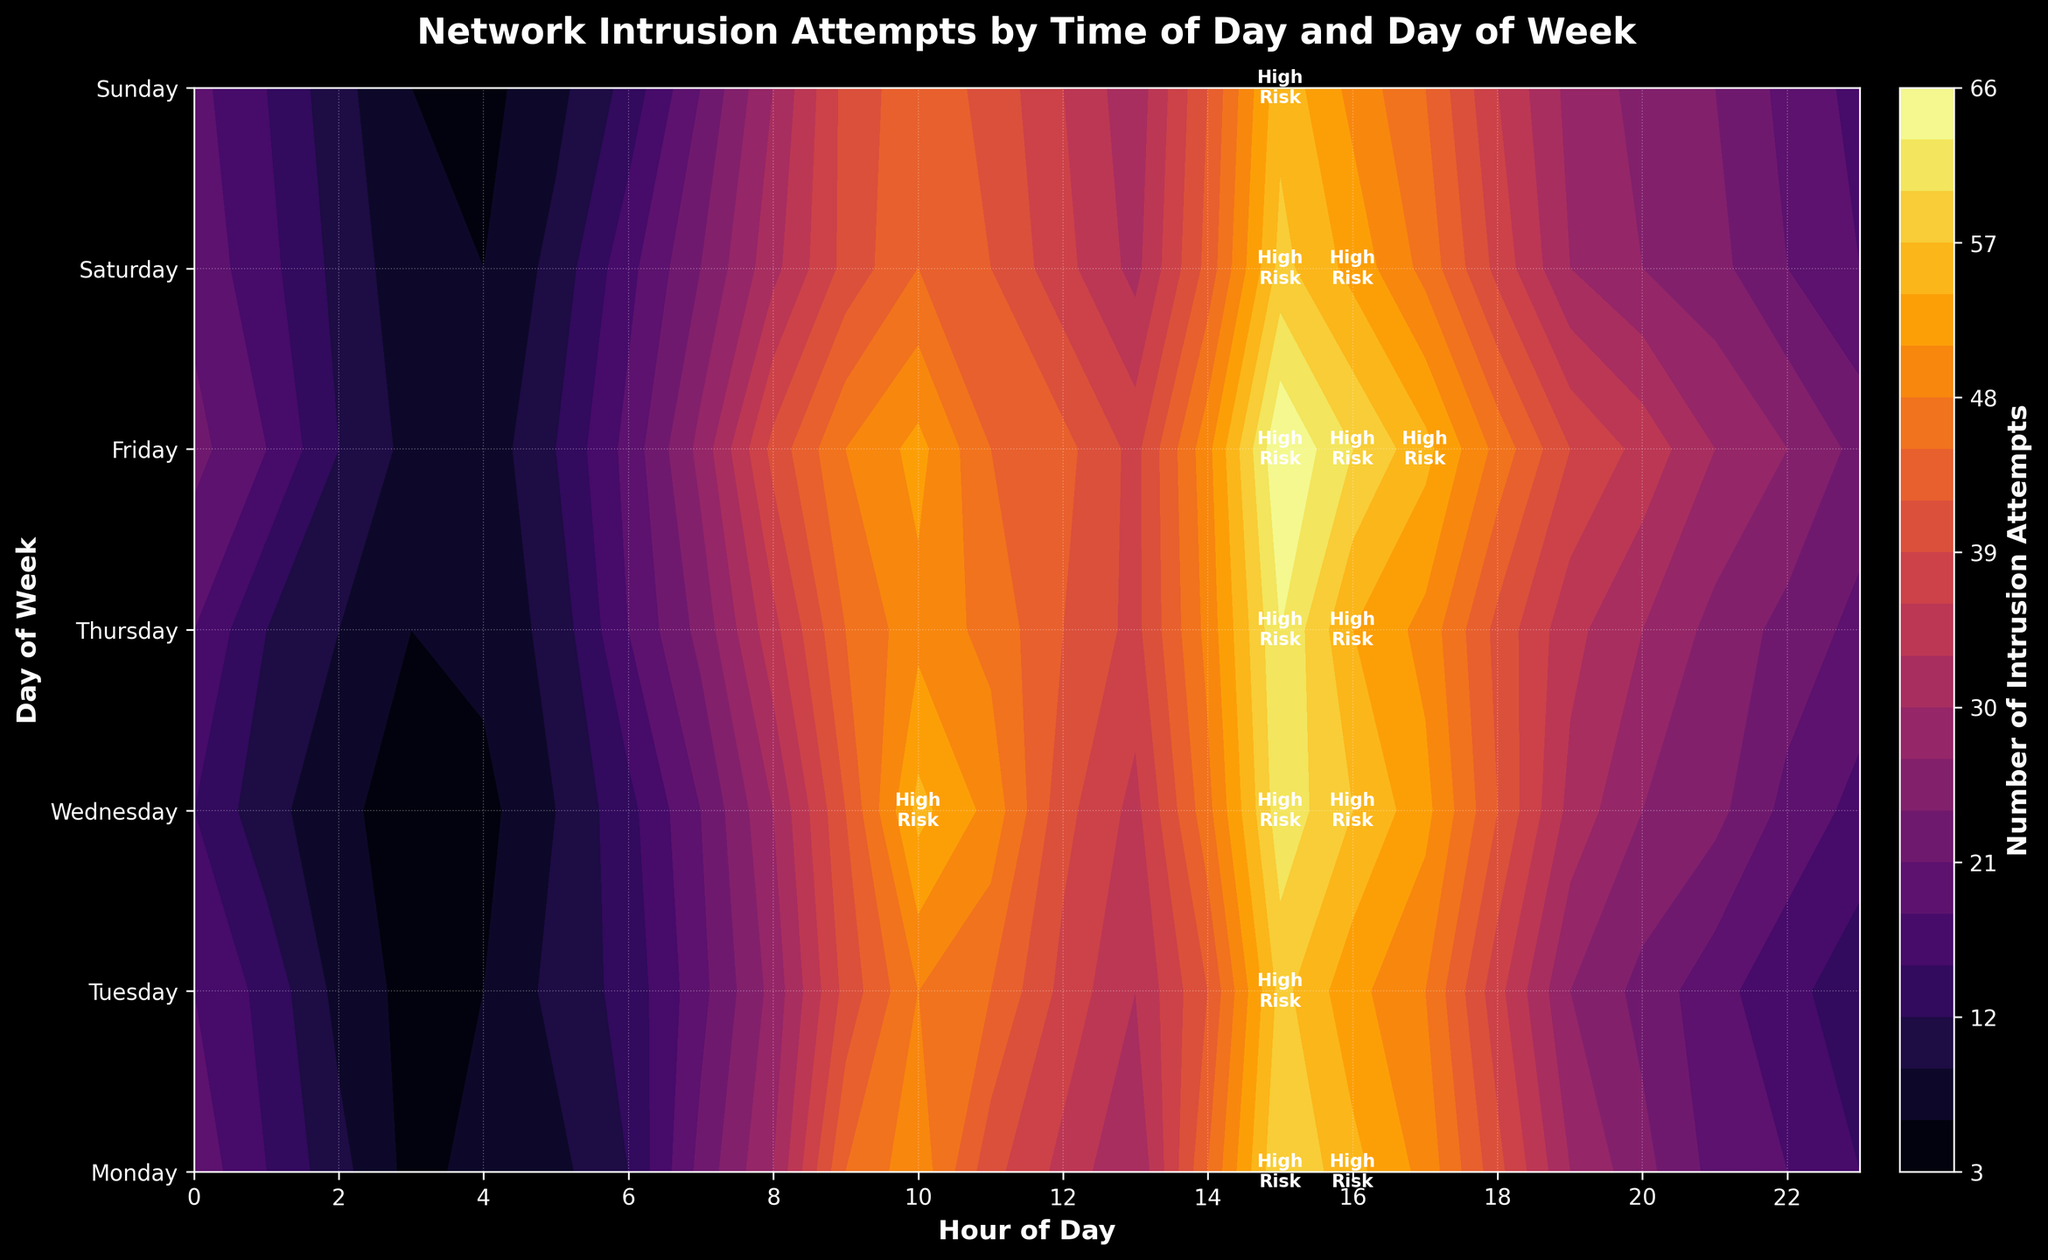What is the title of the figure? The title of the figure is located at the top and is clearly stated in the figure. The title summarizes the content of the plot.
Answer: Network Intrusion Attempts by Time of Day and Day of Week How many intrusion attempts are there at 14:00 on Friday? Find the intersection of "Friday" and the hour "14" in the figure to locate the value representing intrusion attempts at that specific time.
Answer: 50 Which day and hour combination shows the highest number of intrusion attempts? Look for the highest contour level which visually represents the peak value in the plot. Identify the corresponding day and hour on the axes of the plot.
Answer: Friday at 15:00 How does the number of intrusion attempts at 3:00 on Wednesday compare to 3:00 on Thursday? Check the number of intrusion attempts at 3:00 on Wednesday and compare it to the value at 3:00 on Thursday by examining the plot at these intersections.
Answer: Wednesday has 4 attempts and Thursday has 6 attempts Is there any day that appears to consistently have higher intrusion attempts in the afternoon? Compare the overall trend in the colors/contours across different afternoons for each day of the week in the figure and identify any day that stands out as having higher attempts.
Answer: Friday What time of day generally has the least number of intrusion attempts? Analyze the contour levels or colors for all days around each hour to determine the time of day with consistently lower levels.
Answer: Early morning hours (e.g., 3:00) Are there any annotated "High Risk" areas on Saturday? Look for any annotations on the plot that read "High Risk" on the part of the plot corresponding to Saturday.
Answer: Yes, there are "High Risk" annotations around 15:00 How does the number of intrusion attempts change from Monday 8:00 to Monday 12:00? Track the contour levels from 8:00 to 12:00 on Monday and observe the trend in the number of intrusion attempts. Determine if it is increasing, decreasing, or stable.
Answer: Increase from 30 to 35 Which day has the lowest number of intrusion attempts in the early hours (midnight to 3:00)? Compare the number of intrusion attempts from 0:00 to 3:00 for each day of the week by examining the relevant part of the plot for each day.
Answer: Wednesday What color in the contour plot represents the highest number of intrusion attempts? Identify the color gradient used in the contour plot, note the color at the highest contour level, and reference the color bar to determine the color for the highest values.
Answer: Bright yellow 